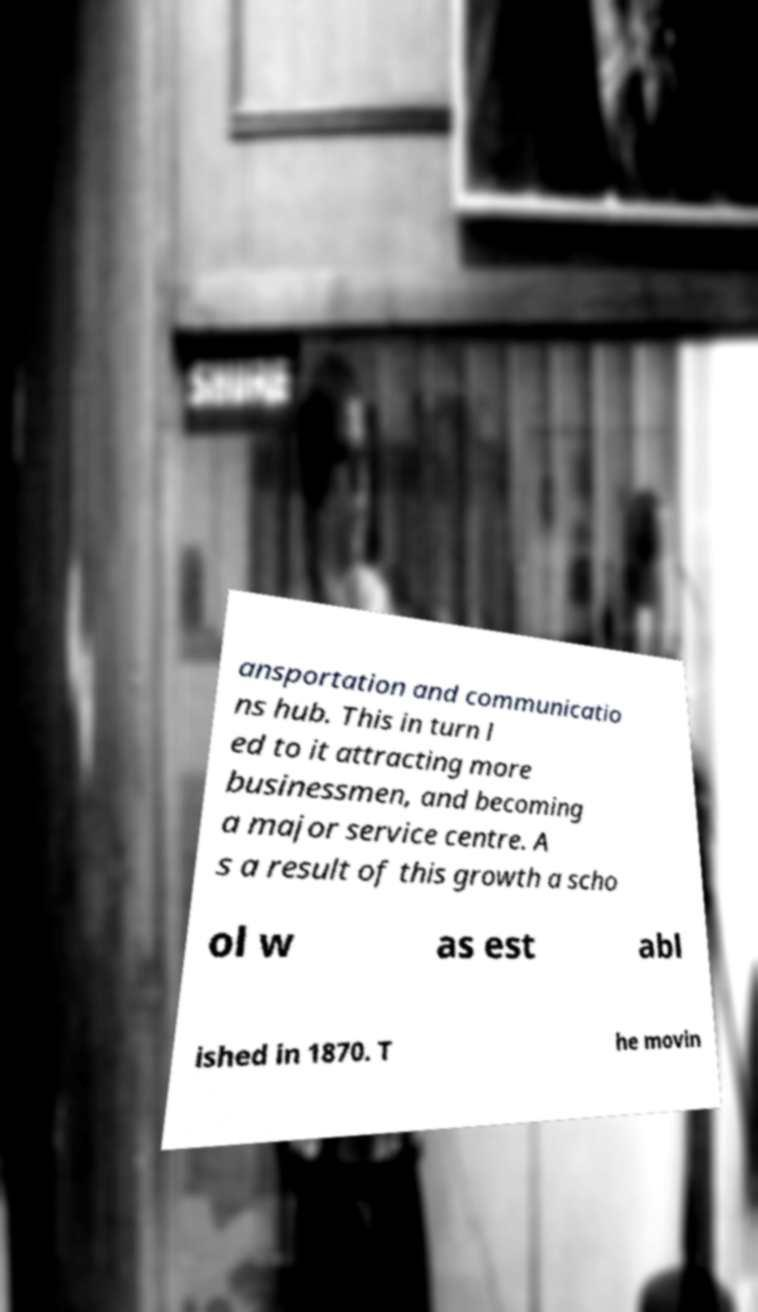Could you assist in decoding the text presented in this image and type it out clearly? ansportation and communicatio ns hub. This in turn l ed to it attracting more businessmen, and becoming a major service centre. A s a result of this growth a scho ol w as est abl ished in 1870. T he movin 